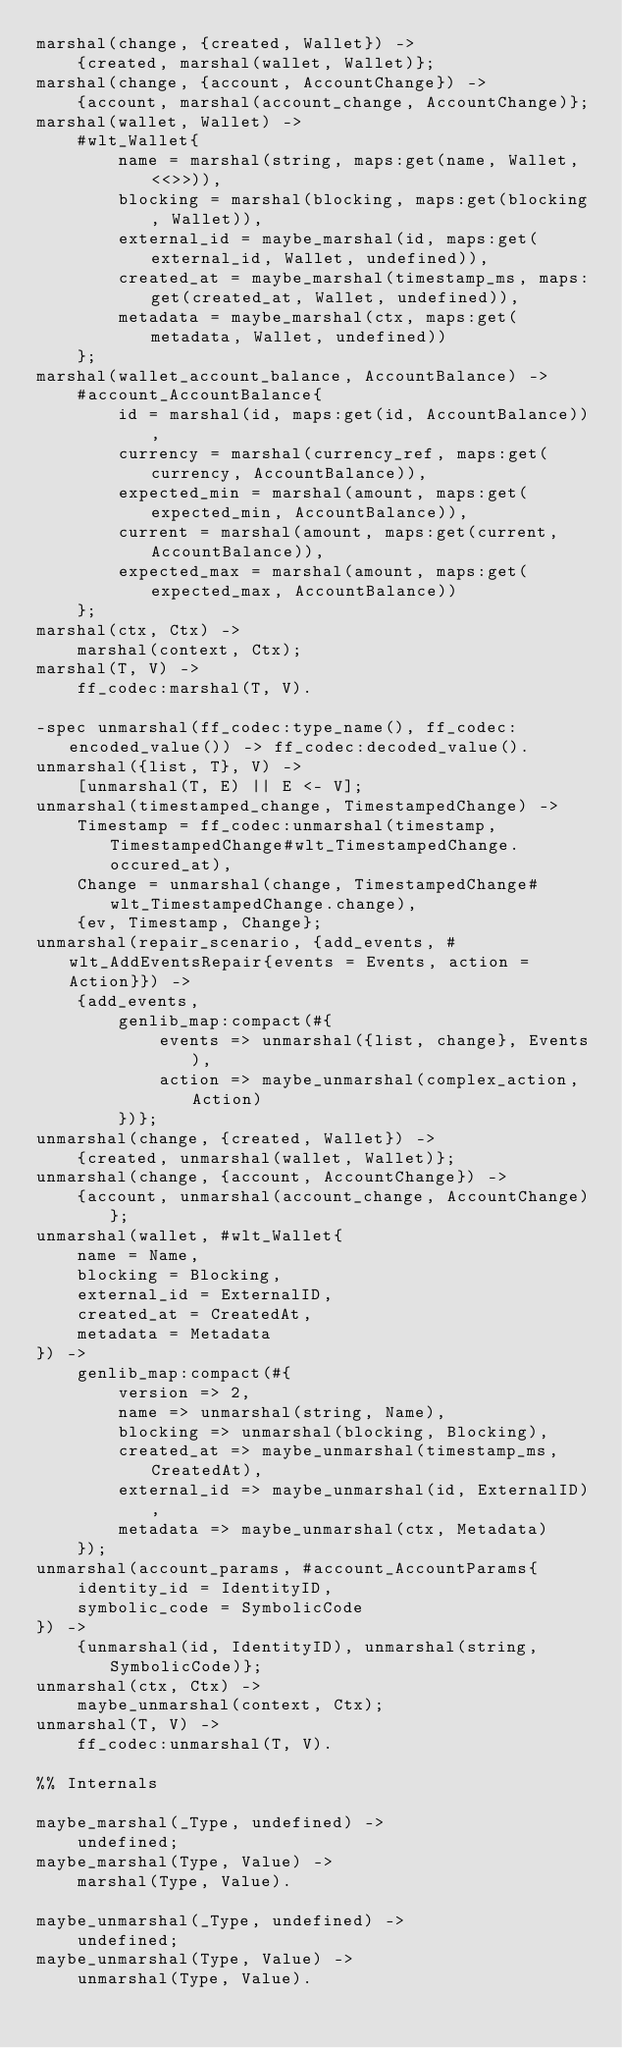Convert code to text. <code><loc_0><loc_0><loc_500><loc_500><_Erlang_>marshal(change, {created, Wallet}) ->
    {created, marshal(wallet, Wallet)};
marshal(change, {account, AccountChange}) ->
    {account, marshal(account_change, AccountChange)};
marshal(wallet, Wallet) ->
    #wlt_Wallet{
        name = marshal(string, maps:get(name, Wallet, <<>>)),
        blocking = marshal(blocking, maps:get(blocking, Wallet)),
        external_id = maybe_marshal(id, maps:get(external_id, Wallet, undefined)),
        created_at = maybe_marshal(timestamp_ms, maps:get(created_at, Wallet, undefined)),
        metadata = maybe_marshal(ctx, maps:get(metadata, Wallet, undefined))
    };
marshal(wallet_account_balance, AccountBalance) ->
    #account_AccountBalance{
        id = marshal(id, maps:get(id, AccountBalance)),
        currency = marshal(currency_ref, maps:get(currency, AccountBalance)),
        expected_min = marshal(amount, maps:get(expected_min, AccountBalance)),
        current = marshal(amount, maps:get(current, AccountBalance)),
        expected_max = marshal(amount, maps:get(expected_max, AccountBalance))
    };
marshal(ctx, Ctx) ->
    marshal(context, Ctx);
marshal(T, V) ->
    ff_codec:marshal(T, V).

-spec unmarshal(ff_codec:type_name(), ff_codec:encoded_value()) -> ff_codec:decoded_value().
unmarshal({list, T}, V) ->
    [unmarshal(T, E) || E <- V];
unmarshal(timestamped_change, TimestampedChange) ->
    Timestamp = ff_codec:unmarshal(timestamp, TimestampedChange#wlt_TimestampedChange.occured_at),
    Change = unmarshal(change, TimestampedChange#wlt_TimestampedChange.change),
    {ev, Timestamp, Change};
unmarshal(repair_scenario, {add_events, #wlt_AddEventsRepair{events = Events, action = Action}}) ->
    {add_events,
        genlib_map:compact(#{
            events => unmarshal({list, change}, Events),
            action => maybe_unmarshal(complex_action, Action)
        })};
unmarshal(change, {created, Wallet}) ->
    {created, unmarshal(wallet, Wallet)};
unmarshal(change, {account, AccountChange}) ->
    {account, unmarshal(account_change, AccountChange)};
unmarshal(wallet, #wlt_Wallet{
    name = Name,
    blocking = Blocking,
    external_id = ExternalID,
    created_at = CreatedAt,
    metadata = Metadata
}) ->
    genlib_map:compact(#{
        version => 2,
        name => unmarshal(string, Name),
        blocking => unmarshal(blocking, Blocking),
        created_at => maybe_unmarshal(timestamp_ms, CreatedAt),
        external_id => maybe_unmarshal(id, ExternalID),
        metadata => maybe_unmarshal(ctx, Metadata)
    });
unmarshal(account_params, #account_AccountParams{
    identity_id = IdentityID,
    symbolic_code = SymbolicCode
}) ->
    {unmarshal(id, IdentityID), unmarshal(string, SymbolicCode)};
unmarshal(ctx, Ctx) ->
    maybe_unmarshal(context, Ctx);
unmarshal(T, V) ->
    ff_codec:unmarshal(T, V).

%% Internals

maybe_marshal(_Type, undefined) ->
    undefined;
maybe_marshal(Type, Value) ->
    marshal(Type, Value).

maybe_unmarshal(_Type, undefined) ->
    undefined;
maybe_unmarshal(Type, Value) ->
    unmarshal(Type, Value).
</code> 